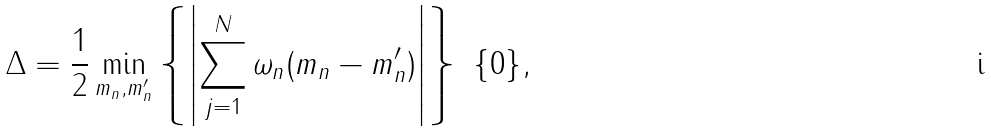<formula> <loc_0><loc_0><loc_500><loc_500>\Delta = \frac { 1 } { 2 } \min _ { m _ { n } , m ^ { \prime } _ { n } } \left \{ \left | \sum _ { j = 1 } ^ { N } \omega _ { n } ( m _ { n } - m _ { n } ^ { \prime } ) \right | \right \} \ \{ 0 \} ,</formula> 